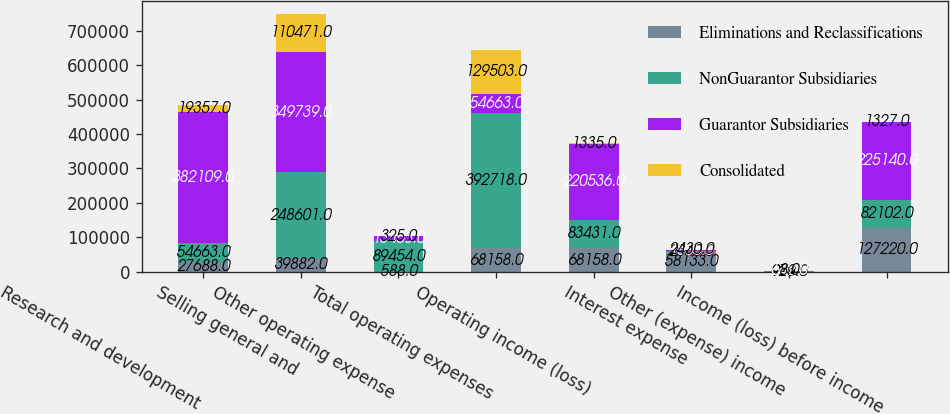Convert chart to OTSL. <chart><loc_0><loc_0><loc_500><loc_500><stacked_bar_chart><ecel><fcel>Research and development<fcel>Selling general and<fcel>Other operating expense<fcel>Total operating expenses<fcel>Operating income (loss)<fcel>Interest expense<fcel>Other (expense) income<fcel>Income (loss) before income<nl><fcel>Eliminations and Reclassifications<fcel>27688<fcel>39882<fcel>588<fcel>68158<fcel>68158<fcel>58133<fcel>929<fcel>127220<nl><fcel>NonGuarantor Subsidiaries<fcel>54663<fcel>248601<fcel>89454<fcel>392718<fcel>83431<fcel>2340<fcel>973<fcel>82102<nl><fcel>Guarantor Subsidiaries<fcel>382109<fcel>349739<fcel>13463<fcel>54663<fcel>220536<fcel>1505<fcel>642<fcel>225140<nl><fcel>Consolidated<fcel>19357<fcel>110471<fcel>325<fcel>129503<fcel>1335<fcel>2430<fcel>8<fcel>1327<nl></chart> 